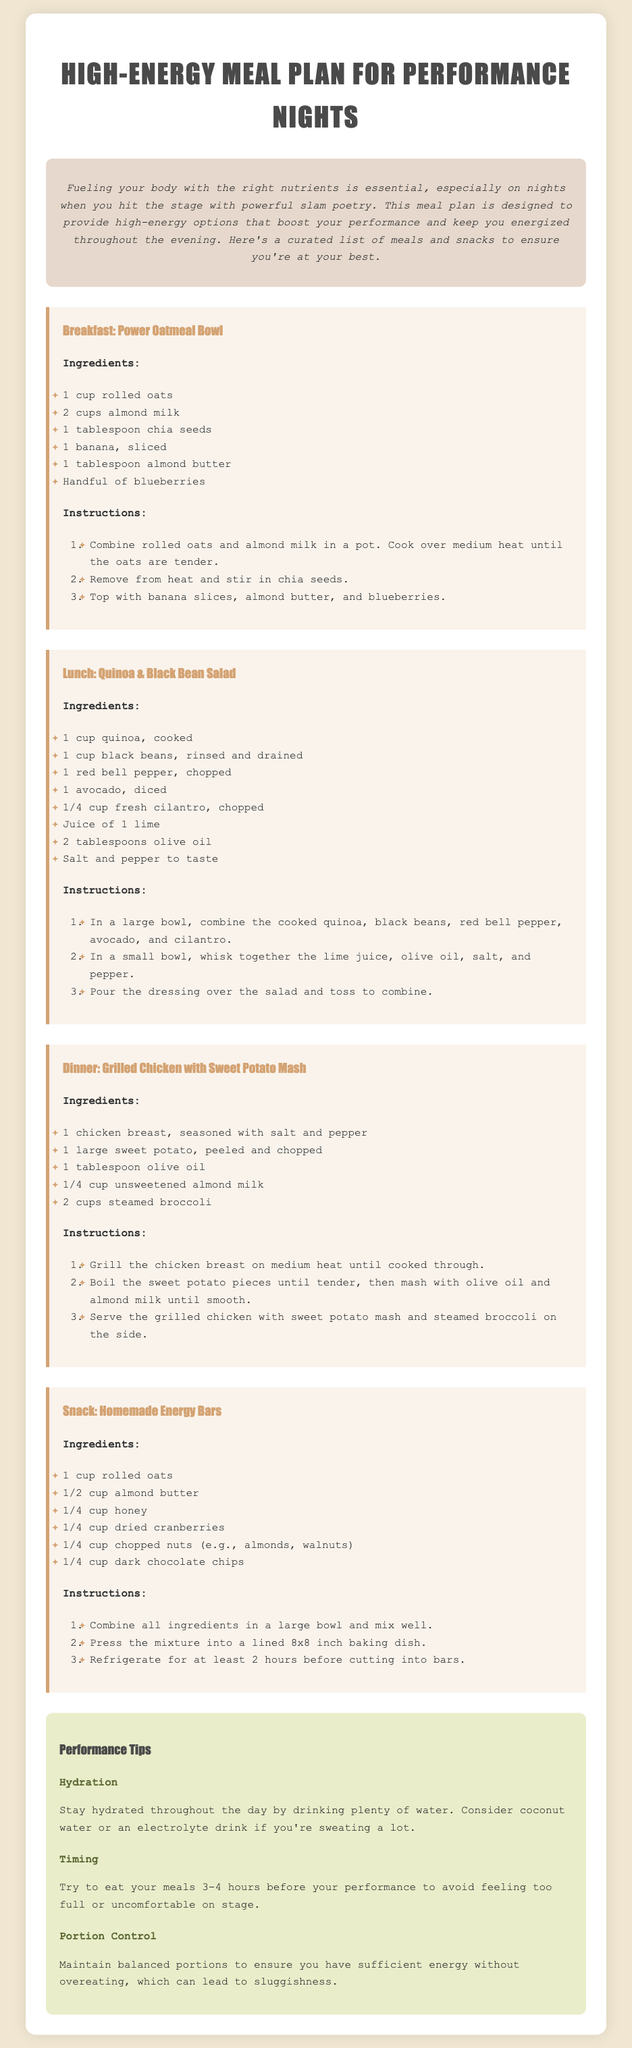What is the title of the meal plan? The title is located in the header of the document, prominently displayed in large text.
Answer: High-Energy Meal Plan for Performance Nights How many cups of almond milk are needed for the Power Oatmeal Bowl? The ingredient list for the Power Oatmeal Bowl specifies the amount of almond milk required.
Answer: 2 cups What is one of the ingredients for the Quinoa & Black Bean Salad? The ingredient list includes several components, one of which is specifically mentioned.
Answer: Black beans What type of chicken is used in the dinner recipe? The meal section describes the kind of chicken utilized in the dinner recipe.
Answer: Chicken breast What should you drink to stay hydrated? The performance tips section mentions recommended beverages for hydration.
Answer: Water What is the recommended eating time before a performance? The timing advice in the tips section suggests an optimal timeframe for meal consumption related to performance.
Answer: 3-4 hours How many ingredients are listed for the Homemade Energy Bars? The ingredient list outlines how many items are required for the recipe.
Answer: 6 What is used to mash the sweet potato in the dinner recipe? The instructions detail what is added to the sweet potato for mashing.
Answer: Almond milk What is the purpose of the meal plan? The introductory section elaborates on the primary objective of the meal plan.
Answer: Fueling your body with the right nutrients 